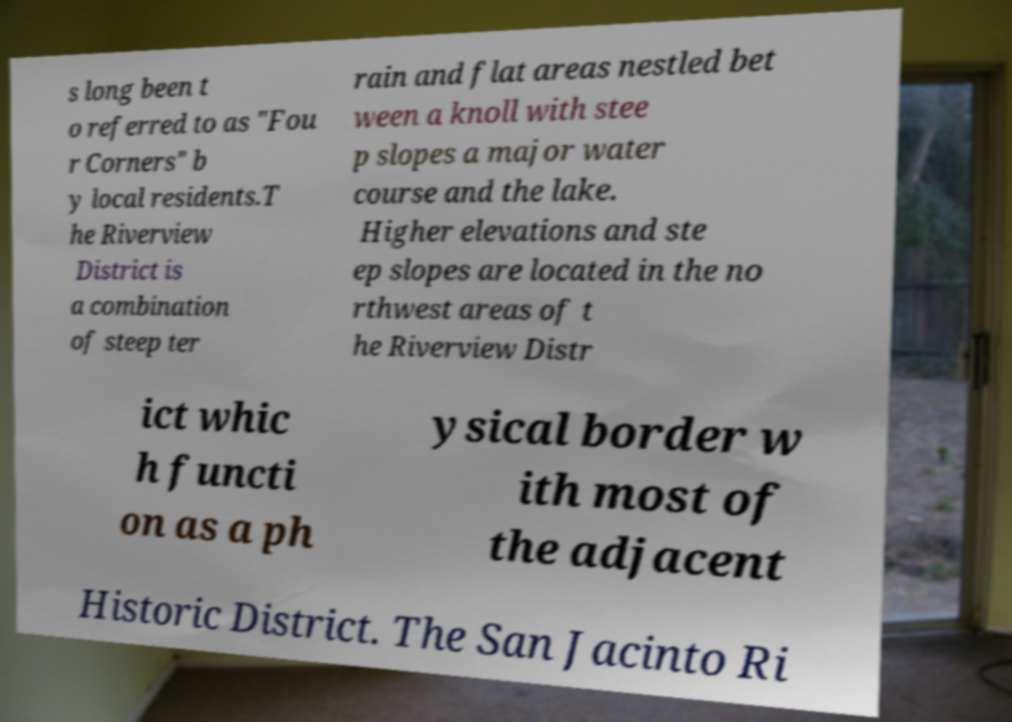Can you read and provide the text displayed in the image?This photo seems to have some interesting text. Can you extract and type it out for me? s long been t o referred to as "Fou r Corners" b y local residents.T he Riverview District is a combination of steep ter rain and flat areas nestled bet ween a knoll with stee p slopes a major water course and the lake. Higher elevations and ste ep slopes are located in the no rthwest areas of t he Riverview Distr ict whic h functi on as a ph ysical border w ith most of the adjacent Historic District. The San Jacinto Ri 